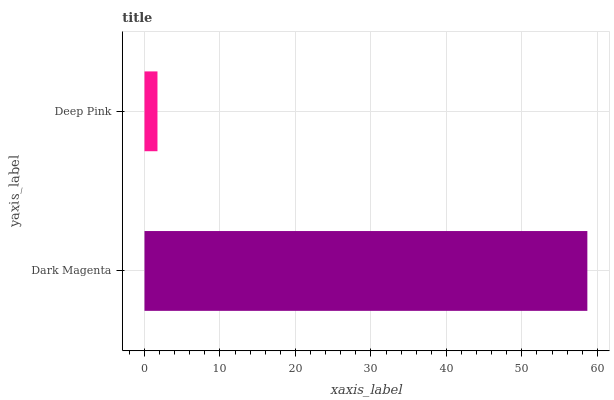Is Deep Pink the minimum?
Answer yes or no. Yes. Is Dark Magenta the maximum?
Answer yes or no. Yes. Is Deep Pink the maximum?
Answer yes or no. No. Is Dark Magenta greater than Deep Pink?
Answer yes or no. Yes. Is Deep Pink less than Dark Magenta?
Answer yes or no. Yes. Is Deep Pink greater than Dark Magenta?
Answer yes or no. No. Is Dark Magenta less than Deep Pink?
Answer yes or no. No. Is Dark Magenta the high median?
Answer yes or no. Yes. Is Deep Pink the low median?
Answer yes or no. Yes. Is Deep Pink the high median?
Answer yes or no. No. Is Dark Magenta the low median?
Answer yes or no. No. 